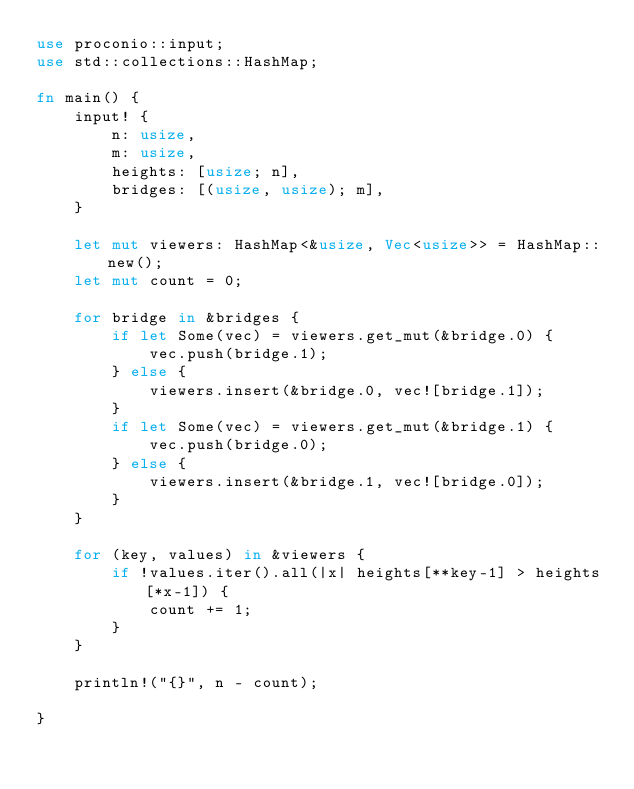Convert code to text. <code><loc_0><loc_0><loc_500><loc_500><_Rust_>use proconio::input;
use std::collections::HashMap;

fn main() {
    input! {
        n: usize,
        m: usize,
        heights: [usize; n],
        bridges: [(usize, usize); m],
    }

    let mut viewers: HashMap<&usize, Vec<usize>> = HashMap::new();
    let mut count = 0;

    for bridge in &bridges {
        if let Some(vec) = viewers.get_mut(&bridge.0) {
            vec.push(bridge.1);
        } else {
            viewers.insert(&bridge.0, vec![bridge.1]);
        }
        if let Some(vec) = viewers.get_mut(&bridge.1) {
            vec.push(bridge.0);
        } else {
            viewers.insert(&bridge.1, vec![bridge.0]);
        }
    }

    for (key, values) in &viewers {
        if !values.iter().all(|x| heights[**key-1] > heights[*x-1]) {
            count += 1;
        }
    }

    println!("{}", n - count);

}
</code> 